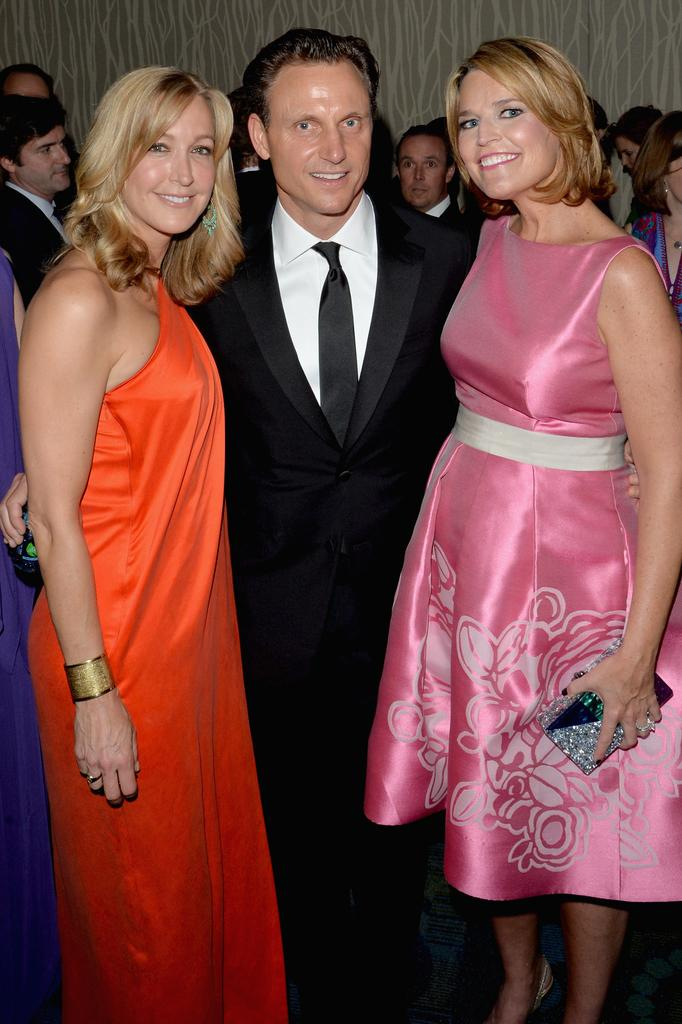How many people are present in the image? There are three people in the image: two women and one man. What are the people in the image doing? The people are standing on the floor. Can you describe the group of people in the background of the image? There is a group of people in the background of the image, but their specific actions or characteristics are not mentioned in the provided facts. Who is the owner of the mark on the man's forehead in the image? There is no mention of a mark on the man's forehead in the provided facts, so it cannot be determined who the owner might be. 